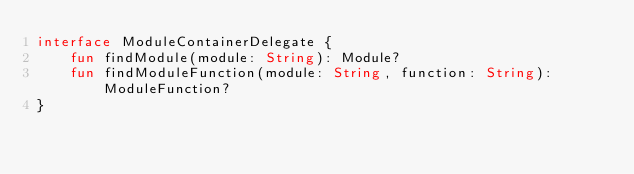Convert code to text. <code><loc_0><loc_0><loc_500><loc_500><_Kotlin_>interface ModuleContainerDelegate {
    fun findModule(module: String): Module?
    fun findModuleFunction(module: String, function: String): ModuleFunction?
}
</code> 